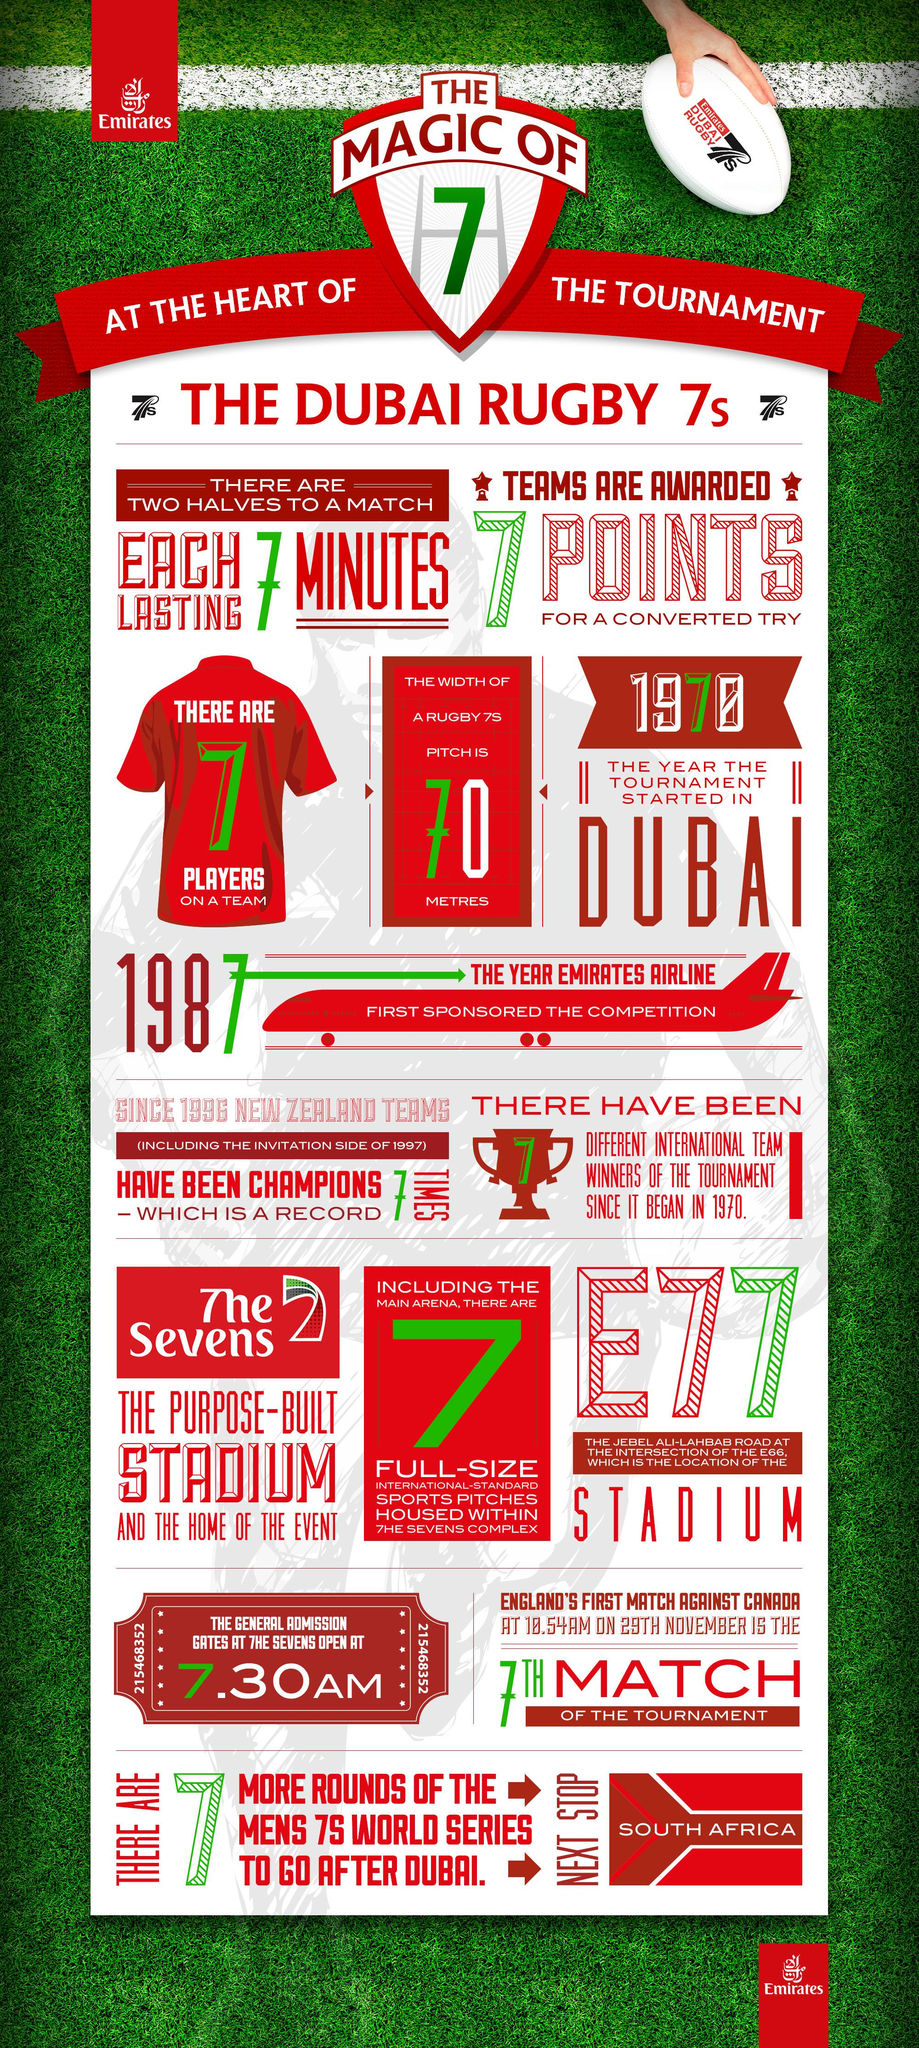Point out several critical features in this image. The Dubai Rugby 7s tournament is held in a stadium, where the Sevens competition takes place annually. In 1987, Emirates Airline became the first sponsor of the Dubai Rugby 7s tournament. The Dubai Sevens, which was founded in 1970, is a celebrated annual rugby event held in Dubai, United Arab Emirates. 